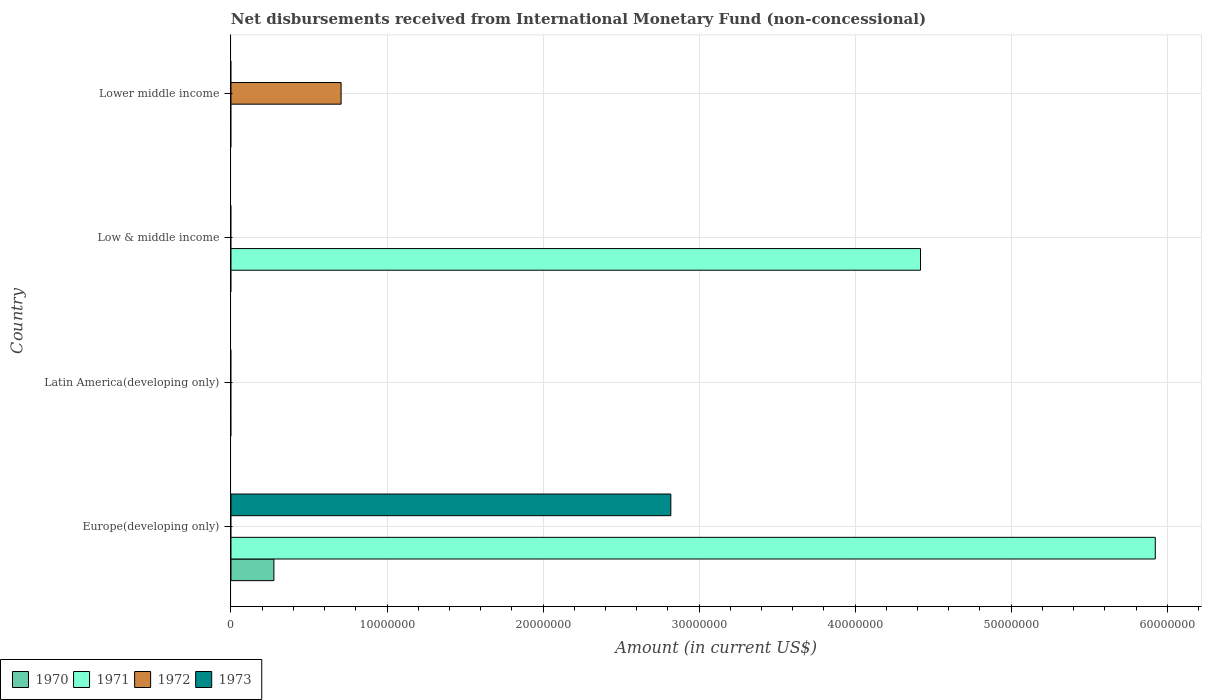Are the number of bars per tick equal to the number of legend labels?
Offer a terse response. No. How many bars are there on the 2nd tick from the top?
Give a very brief answer. 1. How many bars are there on the 2nd tick from the bottom?
Your response must be concise. 0. What is the label of the 4th group of bars from the top?
Ensure brevity in your answer.  Europe(developing only). In how many cases, is the number of bars for a given country not equal to the number of legend labels?
Your answer should be compact. 4. What is the amount of disbursements received from International Monetary Fund in 1973 in Latin America(developing only)?
Your answer should be very brief. 0. Across all countries, what is the maximum amount of disbursements received from International Monetary Fund in 1971?
Give a very brief answer. 5.92e+07. Across all countries, what is the minimum amount of disbursements received from International Monetary Fund in 1970?
Provide a succinct answer. 0. In which country was the amount of disbursements received from International Monetary Fund in 1972 maximum?
Your response must be concise. Lower middle income. What is the total amount of disbursements received from International Monetary Fund in 1971 in the graph?
Your response must be concise. 1.03e+08. What is the difference between the amount of disbursements received from International Monetary Fund in 1971 in Europe(developing only) and the amount of disbursements received from International Monetary Fund in 1970 in Low & middle income?
Make the answer very short. 5.92e+07. What is the average amount of disbursements received from International Monetary Fund in 1972 per country?
Provide a short and direct response. 1.76e+06. What is the difference between the amount of disbursements received from International Monetary Fund in 1971 and amount of disbursements received from International Monetary Fund in 1970 in Europe(developing only)?
Give a very brief answer. 5.65e+07. In how many countries, is the amount of disbursements received from International Monetary Fund in 1970 greater than 28000000 US$?
Provide a succinct answer. 0. What is the difference between the highest and the lowest amount of disbursements received from International Monetary Fund in 1972?
Keep it short and to the point. 7.06e+06. In how many countries, is the amount of disbursements received from International Monetary Fund in 1971 greater than the average amount of disbursements received from International Monetary Fund in 1971 taken over all countries?
Provide a short and direct response. 2. Is it the case that in every country, the sum of the amount of disbursements received from International Monetary Fund in 1970 and amount of disbursements received from International Monetary Fund in 1972 is greater than the sum of amount of disbursements received from International Monetary Fund in 1971 and amount of disbursements received from International Monetary Fund in 1973?
Offer a terse response. No. How many bars are there?
Your answer should be very brief. 5. Are all the bars in the graph horizontal?
Your response must be concise. Yes. What is the difference between two consecutive major ticks on the X-axis?
Ensure brevity in your answer.  1.00e+07. Does the graph contain any zero values?
Provide a short and direct response. Yes. How are the legend labels stacked?
Keep it short and to the point. Horizontal. What is the title of the graph?
Ensure brevity in your answer.  Net disbursements received from International Monetary Fund (non-concessional). Does "1985" appear as one of the legend labels in the graph?
Provide a short and direct response. No. What is the Amount (in current US$) of 1970 in Europe(developing only)?
Provide a succinct answer. 2.75e+06. What is the Amount (in current US$) in 1971 in Europe(developing only)?
Offer a terse response. 5.92e+07. What is the Amount (in current US$) of 1973 in Europe(developing only)?
Make the answer very short. 2.82e+07. What is the Amount (in current US$) of 1970 in Latin America(developing only)?
Offer a very short reply. 0. What is the Amount (in current US$) in 1971 in Latin America(developing only)?
Your answer should be very brief. 0. What is the Amount (in current US$) of 1973 in Latin America(developing only)?
Provide a succinct answer. 0. What is the Amount (in current US$) in 1970 in Low & middle income?
Keep it short and to the point. 0. What is the Amount (in current US$) of 1971 in Low & middle income?
Offer a terse response. 4.42e+07. What is the Amount (in current US$) of 1970 in Lower middle income?
Make the answer very short. 0. What is the Amount (in current US$) in 1971 in Lower middle income?
Your answer should be very brief. 0. What is the Amount (in current US$) of 1972 in Lower middle income?
Your answer should be compact. 7.06e+06. What is the Amount (in current US$) in 1973 in Lower middle income?
Give a very brief answer. 0. Across all countries, what is the maximum Amount (in current US$) in 1970?
Offer a terse response. 2.75e+06. Across all countries, what is the maximum Amount (in current US$) of 1971?
Your answer should be compact. 5.92e+07. Across all countries, what is the maximum Amount (in current US$) of 1972?
Your answer should be compact. 7.06e+06. Across all countries, what is the maximum Amount (in current US$) of 1973?
Offer a terse response. 2.82e+07. Across all countries, what is the minimum Amount (in current US$) in 1971?
Give a very brief answer. 0. Across all countries, what is the minimum Amount (in current US$) of 1973?
Give a very brief answer. 0. What is the total Amount (in current US$) of 1970 in the graph?
Your answer should be very brief. 2.75e+06. What is the total Amount (in current US$) of 1971 in the graph?
Offer a very short reply. 1.03e+08. What is the total Amount (in current US$) of 1972 in the graph?
Provide a short and direct response. 7.06e+06. What is the total Amount (in current US$) of 1973 in the graph?
Provide a short and direct response. 2.82e+07. What is the difference between the Amount (in current US$) in 1971 in Europe(developing only) and that in Low & middle income?
Make the answer very short. 1.50e+07. What is the difference between the Amount (in current US$) in 1970 in Europe(developing only) and the Amount (in current US$) in 1971 in Low & middle income?
Offer a terse response. -4.14e+07. What is the difference between the Amount (in current US$) in 1970 in Europe(developing only) and the Amount (in current US$) in 1972 in Lower middle income?
Your answer should be very brief. -4.31e+06. What is the difference between the Amount (in current US$) in 1971 in Europe(developing only) and the Amount (in current US$) in 1972 in Lower middle income?
Your answer should be very brief. 5.22e+07. What is the difference between the Amount (in current US$) in 1971 in Low & middle income and the Amount (in current US$) in 1972 in Lower middle income?
Provide a succinct answer. 3.71e+07. What is the average Amount (in current US$) in 1970 per country?
Your response must be concise. 6.88e+05. What is the average Amount (in current US$) of 1971 per country?
Ensure brevity in your answer.  2.59e+07. What is the average Amount (in current US$) of 1972 per country?
Give a very brief answer. 1.76e+06. What is the average Amount (in current US$) in 1973 per country?
Offer a very short reply. 7.05e+06. What is the difference between the Amount (in current US$) in 1970 and Amount (in current US$) in 1971 in Europe(developing only)?
Ensure brevity in your answer.  -5.65e+07. What is the difference between the Amount (in current US$) of 1970 and Amount (in current US$) of 1973 in Europe(developing only)?
Ensure brevity in your answer.  -2.54e+07. What is the difference between the Amount (in current US$) of 1971 and Amount (in current US$) of 1973 in Europe(developing only)?
Offer a very short reply. 3.10e+07. What is the ratio of the Amount (in current US$) of 1971 in Europe(developing only) to that in Low & middle income?
Offer a terse response. 1.34. What is the difference between the highest and the lowest Amount (in current US$) of 1970?
Provide a succinct answer. 2.75e+06. What is the difference between the highest and the lowest Amount (in current US$) in 1971?
Provide a short and direct response. 5.92e+07. What is the difference between the highest and the lowest Amount (in current US$) of 1972?
Offer a very short reply. 7.06e+06. What is the difference between the highest and the lowest Amount (in current US$) of 1973?
Ensure brevity in your answer.  2.82e+07. 